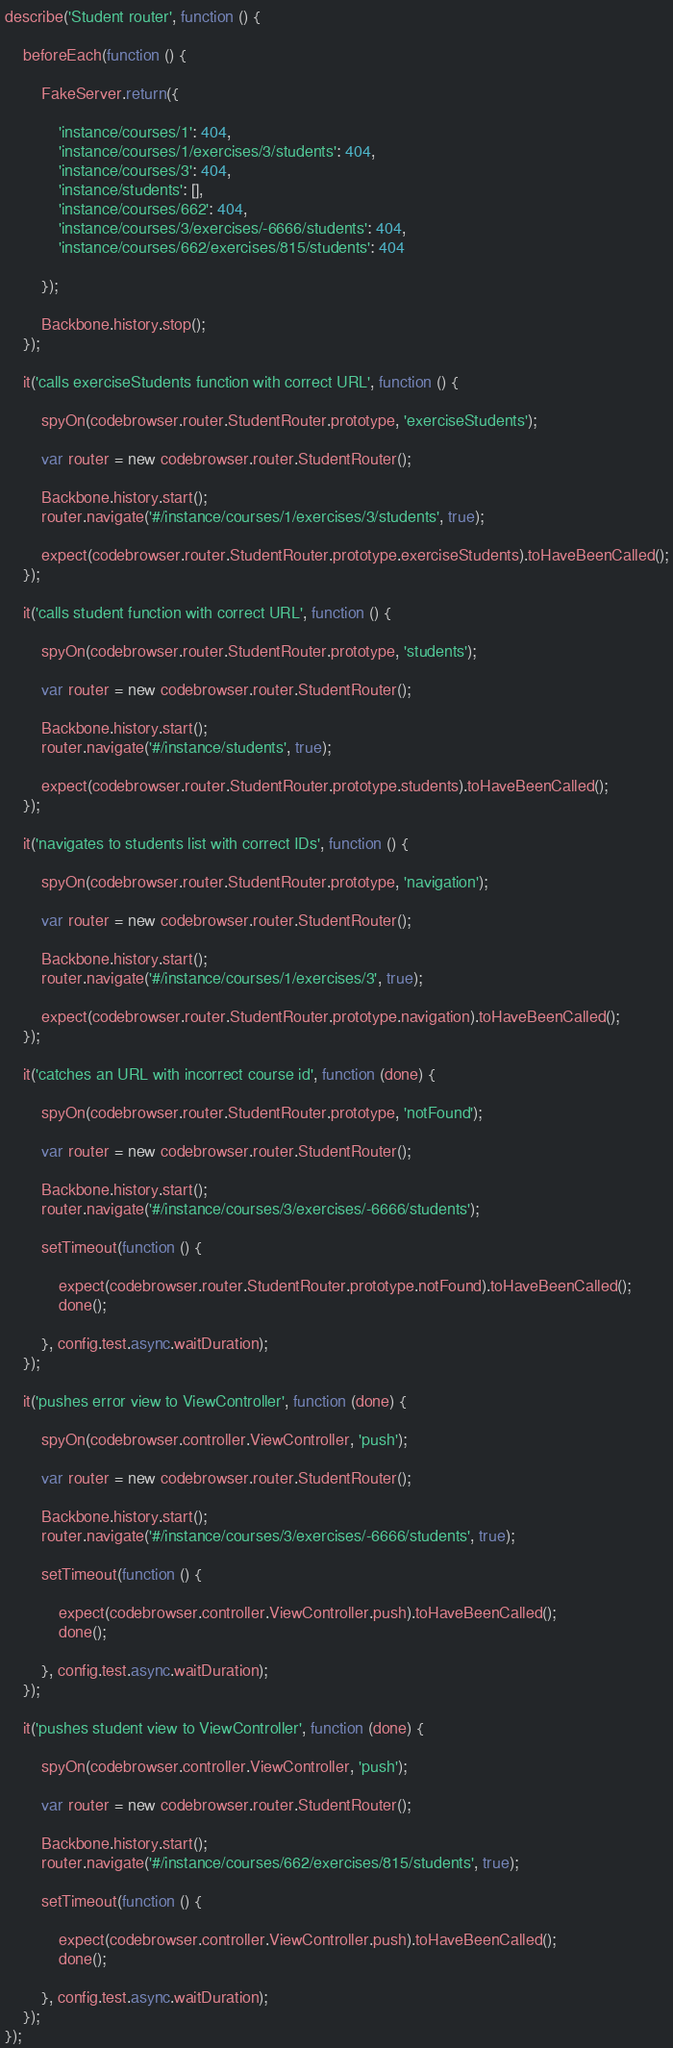<code> <loc_0><loc_0><loc_500><loc_500><_JavaScript_>describe('Student router', function () {

    beforeEach(function () {

        FakeServer.return({

            'instance/courses/1': 404,
            'instance/courses/1/exercises/3/students': 404,
            'instance/courses/3': 404,
            'instance/students': [],
            'instance/courses/662': 404,
            'instance/courses/3/exercises/-6666/students': 404,
            'instance/courses/662/exercises/815/students': 404

        });

        Backbone.history.stop();
    });

    it('calls exerciseStudents function with correct URL', function () {

        spyOn(codebrowser.router.StudentRouter.prototype, 'exerciseStudents');

        var router = new codebrowser.router.StudentRouter();

        Backbone.history.start();
        router.navigate('#/instance/courses/1/exercises/3/students', true);

        expect(codebrowser.router.StudentRouter.prototype.exerciseStudents).toHaveBeenCalled();
    });

    it('calls student function with correct URL', function () {

        spyOn(codebrowser.router.StudentRouter.prototype, 'students');

        var router = new codebrowser.router.StudentRouter();

        Backbone.history.start();
        router.navigate('#/instance/students', true);

        expect(codebrowser.router.StudentRouter.prototype.students).toHaveBeenCalled();
    });

    it('navigates to students list with correct IDs', function () {

        spyOn(codebrowser.router.StudentRouter.prototype, 'navigation');

        var router = new codebrowser.router.StudentRouter();

        Backbone.history.start();
        router.navigate('#/instance/courses/1/exercises/3', true);

        expect(codebrowser.router.StudentRouter.prototype.navigation).toHaveBeenCalled();
    });

    it('catches an URL with incorrect course id', function (done) {

        spyOn(codebrowser.router.StudentRouter.prototype, 'notFound');

        var router = new codebrowser.router.StudentRouter();

        Backbone.history.start();
        router.navigate('#/instance/courses/3/exercises/-6666/students');

        setTimeout(function () {

            expect(codebrowser.router.StudentRouter.prototype.notFound).toHaveBeenCalled();
            done();

        }, config.test.async.waitDuration);
    });

    it('pushes error view to ViewController', function (done) {

        spyOn(codebrowser.controller.ViewController, 'push');

        var router = new codebrowser.router.StudentRouter();

        Backbone.history.start();
        router.navigate('#/instance/courses/3/exercises/-6666/students', true);

        setTimeout(function () {

            expect(codebrowser.controller.ViewController.push).toHaveBeenCalled();
            done();

        }, config.test.async.waitDuration);
    });

    it('pushes student view to ViewController', function (done) {

        spyOn(codebrowser.controller.ViewController, 'push');

        var router = new codebrowser.router.StudentRouter();

        Backbone.history.start();
        router.navigate('#/instance/courses/662/exercises/815/students', true);

        setTimeout(function () {

            expect(codebrowser.controller.ViewController.push).toHaveBeenCalled();
            done();

        }, config.test.async.waitDuration);
    });
});
</code> 